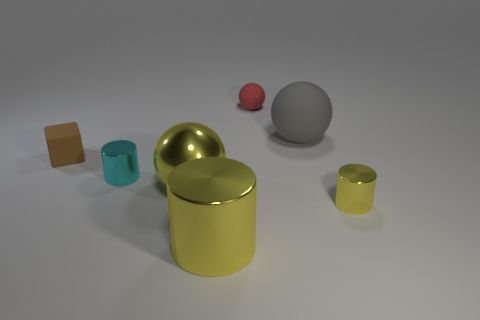The rubber block is what color?
Give a very brief answer. Brown. The tiny object that is the same shape as the big gray thing is what color?
Provide a short and direct response. Red. How many cyan objects have the same shape as the large gray object?
Give a very brief answer. 0. How many objects are either shiny cylinders or cylinders on the left side of the tiny yellow object?
Ensure brevity in your answer.  3. There is a tiny block; is it the same color as the tiny cylinder to the left of the tiny yellow object?
Your answer should be compact. No. What size is the cylinder that is behind the large yellow cylinder and on the right side of the yellow ball?
Provide a succinct answer. Small. There is a brown rubber object; are there any metal objects on the left side of it?
Ensure brevity in your answer.  No. There is a big sphere behind the tiny brown matte thing; are there any large yellow metallic cylinders that are behind it?
Ensure brevity in your answer.  No. Are there an equal number of metallic cylinders behind the small brown rubber cube and objects behind the large rubber sphere?
Offer a terse response. No. There is another tiny cylinder that is the same material as the small cyan cylinder; what color is it?
Your answer should be very brief. Yellow. 